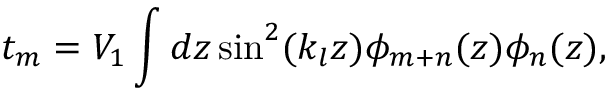Convert formula to latex. <formula><loc_0><loc_0><loc_500><loc_500>t _ { m } = V _ { 1 } \int d z \sin ^ { 2 } ( k _ { l } z ) \phi _ { m + n } ( z ) \phi _ { n } ( z ) ,</formula> 